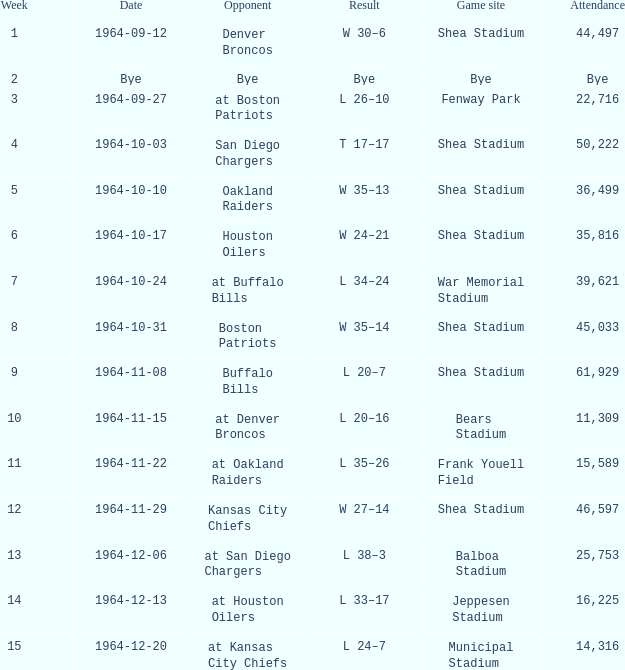What's the Result for week 15? L 24–7. 